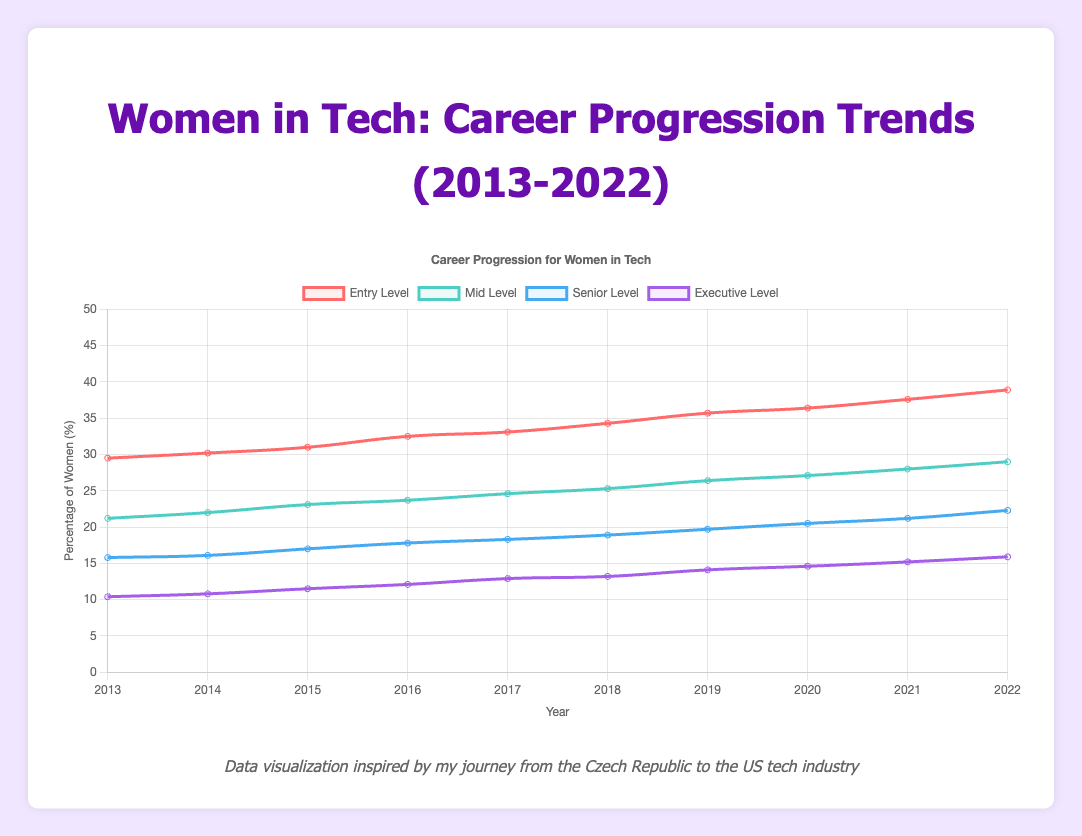What's the trend for the percentage of women in executive-level positions from 2013 to 2022? The trend for the percentage of women in executive-level positions from 2013 to 2022 shows a steady increase from 10.4% in 2013 to 15.9% in 2022.
Answer: steady increase In which year did the percentage of women in mid-level positions surpass 25%? The percentage of women in mid-level positions surpassed 25% in the year 2018.
Answer: 2018 Compare the percentages of women at entry-level and senior-level positions in 2015. Which is higher, and by how much? In 2015, the percentage of women at entry-level positions was 31.0%, whereas the percentage at senior-level positions was 17.0%. The entry-level percentage is higher by 31.0% - 17.0% = 14.0%.
Answer: Entry-level, by 14.0% What's the average percentage of women in mid-level positions over the decade? To find the average percentage of women in mid-level positions over the decade, sum the percentages for each year and divide by the number of years: (21.2 + 22.0 + 23.1 + 23.7 + 24.6 + 25.3 + 26.4 + 27.1 + 28.0 + 29.0) / 10 = 24.04%.
Answer: 24.04% What's the combined total of mentorship programs, networking events, and leadership training sessions provided by Google in 2022? To find the combined total, add the number of mentorship programs, networking events, and leadership training sessions provided by Google in 2022: 15 + 22 + 18 = 55.
Answer: 55 How does the percentage of women in senior-level positions in 2018 compare to that in 2022? In 2018, the percentage of women in senior-level positions was 18.9%, whereas in 2022 it was 22.3%. The percentage increased by 22.3% - 18.9% = 3.4% over these years.
Answer: increased by 3.4% What is the difference between the percentage of women in mid-level positions in 2016 and executive-level positions in 2018? The percentage of women in mid-level positions in 2016 was 23.7%, and the percentage of women in executive-level positions in 2018 was 13.2%. The difference is 23.7% - 13.2% = 10.5%.
Answer: 10.5% How many more networking events does Facebook host compared to Amazon according to the 2022 data? According to the 2022 data, Facebook hosts 21 networking events, while Amazon hosts 18. The difference is 21 - 18 = 3 events.
Answer: 3 What is the trend in the percentage of women at the entry level over the displayed years, and what might it suggest? The trend in the percentage of women at the entry level over the years shows a consistent increase from 29.5% in 2013 to 38.9% in 2022. This steady rise suggests that more women are entering the tech industry at the entry level.
Answer: steady rise, more women entering 